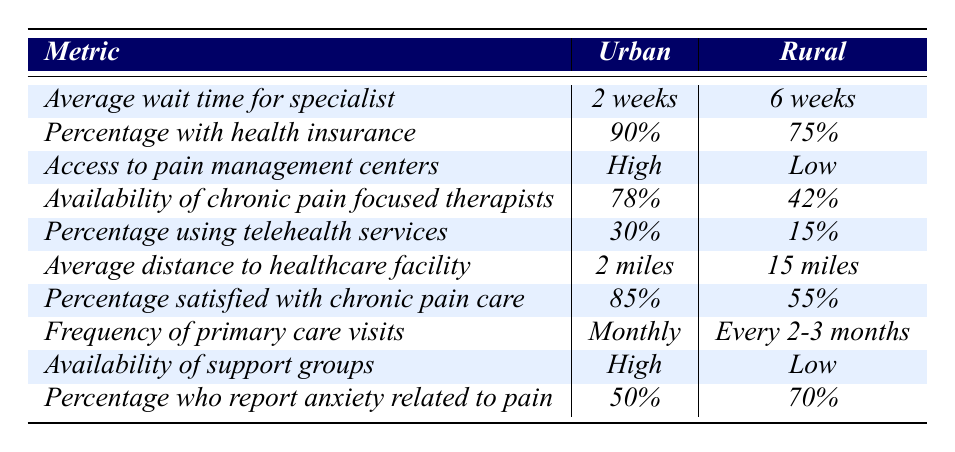What is the average wait time for a specialist in urban settings? According to the table, the average wait time for a specialist in urban settings is listed as "2 weeks".
Answer: 2 weeks What percentage of rural patients have health insurance? The table indicates that 75% of rural patients have health insurance.
Answer: 75% Is access to pain management centers reported as high in urban areas? The table specifies that access to pain management centers in urban areas is categorized as "High".
Answer: Yes How much longer is the average wait time for a specialist in rural settings compared to urban settings? The average wait time for specialists in rural settings is 6 weeks, and in urban settings, it is 2 weeks. The difference is calculated as 6 weeks - 2 weeks = 4 weeks.
Answer: 4 weeks What is the percentage of patients using telehealth services in urban settings compared to rural settings? Urban settings report 30% usage, while rural settings report 15%. The difference is 30% - 15% = 15%.
Answer: 15% Which group has a higher percentage of satisfaction with chronic pain care? Urban settings have a satisfaction rate of 85%, while rural settings have 55%. 85% is greater than 55%, indicating that urban patients report higher satisfaction.
Answer: Urban What is the average distance to healthcare facilities for rural patients, and how does it compare to urban patients? The average distance for rural patients is 15 miles, while for urban patients it is 2 miles. The comparison shows that rural patients are 13 miles further from healthcare facilities than urban patients (15 miles - 2 miles = 13 miles).
Answer: 13 miles Is the frequency of primary care visits more frequent for urban or rural patients? Urban patients have a frequency of "Monthly" visits compared to "Every 2-3 months" for rural patients, indicating urban patients have more frequent visits.
Answer: Urban patients What percentage of rural patients report anxiety related to chronic pain compared to urban patients? The table shows that 70% of rural patients report anxiety related to pain, while 50% of urban patients do. Rural patients have a higher percentage by subtracting 50% from 70%, resulting in a difference of 20%.
Answer: 20% How does the availability of chronic pain-focused therapists compare between urban and rural settings? The table states that 78% of urban patients have access to chronic pain-focused therapists, while only 42% of rural patients have the same access. Therefore, urban settings have a significantly higher percentage of available therapists.
Answer: Higher in urban settings 